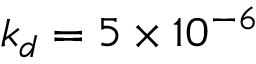<formula> <loc_0><loc_0><loc_500><loc_500>k _ { d } = 5 \times 1 0 ^ { - 6 }</formula> 